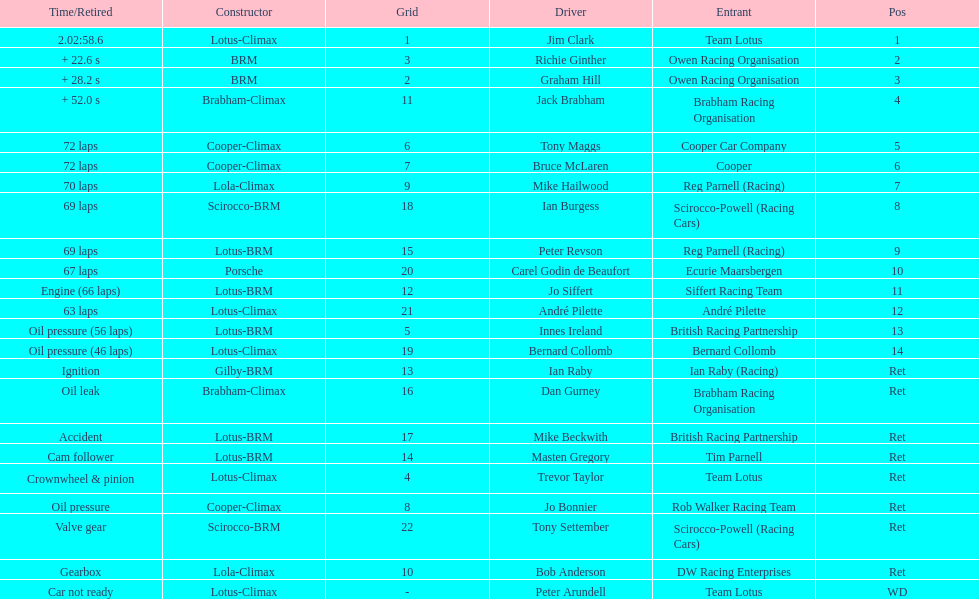Which driver did not have his/her car ready? Peter Arundell. 